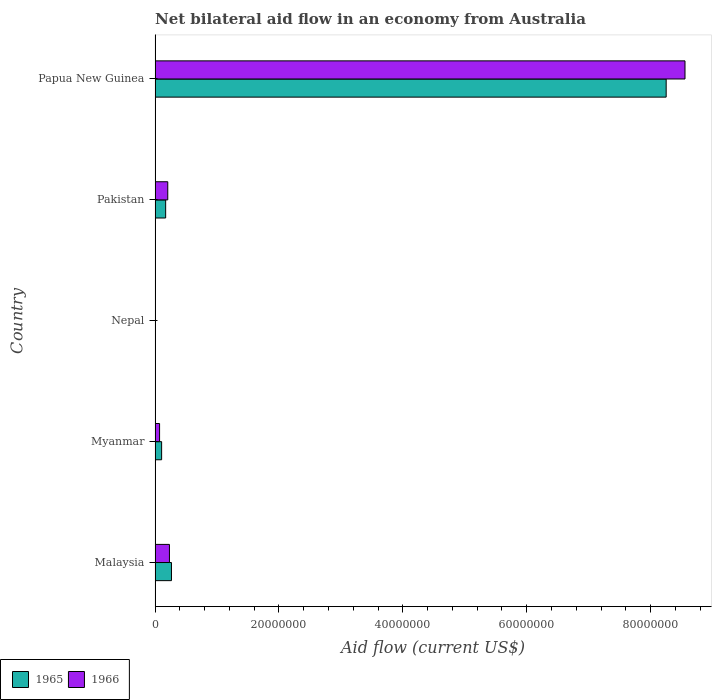How many different coloured bars are there?
Provide a succinct answer. 2. Are the number of bars on each tick of the Y-axis equal?
Make the answer very short. Yes. How many bars are there on the 3rd tick from the bottom?
Ensure brevity in your answer.  2. What is the label of the 4th group of bars from the top?
Your answer should be very brief. Myanmar. Across all countries, what is the maximum net bilateral aid flow in 1966?
Provide a short and direct response. 8.56e+07. Across all countries, what is the minimum net bilateral aid flow in 1965?
Provide a succinct answer. 5.00e+04. In which country was the net bilateral aid flow in 1966 maximum?
Provide a short and direct response. Papua New Guinea. In which country was the net bilateral aid flow in 1965 minimum?
Provide a succinct answer. Nepal. What is the total net bilateral aid flow in 1965 in the graph?
Your response must be concise. 8.80e+07. What is the difference between the net bilateral aid flow in 1966 in Malaysia and that in Myanmar?
Your answer should be very brief. 1.59e+06. What is the difference between the net bilateral aid flow in 1966 in Nepal and the net bilateral aid flow in 1965 in Pakistan?
Provide a succinct answer. -1.65e+06. What is the average net bilateral aid flow in 1966 per country?
Provide a succinct answer. 1.81e+07. What is the ratio of the net bilateral aid flow in 1965 in Myanmar to that in Papua New Guinea?
Ensure brevity in your answer.  0.01. Is the net bilateral aid flow in 1966 in Nepal less than that in Pakistan?
Ensure brevity in your answer.  Yes. Is the difference between the net bilateral aid flow in 1965 in Malaysia and Papua New Guinea greater than the difference between the net bilateral aid flow in 1966 in Malaysia and Papua New Guinea?
Provide a succinct answer. Yes. What is the difference between the highest and the second highest net bilateral aid flow in 1966?
Your response must be concise. 8.32e+07. What is the difference between the highest and the lowest net bilateral aid flow in 1966?
Make the answer very short. 8.55e+07. In how many countries, is the net bilateral aid flow in 1966 greater than the average net bilateral aid flow in 1966 taken over all countries?
Provide a short and direct response. 1. Is the sum of the net bilateral aid flow in 1966 in Myanmar and Nepal greater than the maximum net bilateral aid flow in 1965 across all countries?
Keep it short and to the point. No. What does the 1st bar from the top in Pakistan represents?
Ensure brevity in your answer.  1966. What does the 2nd bar from the bottom in Myanmar represents?
Give a very brief answer. 1966. How are the legend labels stacked?
Give a very brief answer. Horizontal. What is the title of the graph?
Your response must be concise. Net bilateral aid flow in an economy from Australia. What is the label or title of the X-axis?
Keep it short and to the point. Aid flow (current US$). What is the label or title of the Y-axis?
Your response must be concise. Country. What is the Aid flow (current US$) of 1965 in Malaysia?
Ensure brevity in your answer.  2.65e+06. What is the Aid flow (current US$) in 1966 in Malaysia?
Make the answer very short. 2.32e+06. What is the Aid flow (current US$) in 1965 in Myanmar?
Ensure brevity in your answer.  1.06e+06. What is the Aid flow (current US$) in 1966 in Myanmar?
Offer a terse response. 7.30e+05. What is the Aid flow (current US$) of 1965 in Pakistan?
Your answer should be compact. 1.71e+06. What is the Aid flow (current US$) in 1966 in Pakistan?
Your answer should be very brief. 2.05e+06. What is the Aid flow (current US$) of 1965 in Papua New Guinea?
Make the answer very short. 8.25e+07. What is the Aid flow (current US$) of 1966 in Papua New Guinea?
Offer a very short reply. 8.56e+07. Across all countries, what is the maximum Aid flow (current US$) of 1965?
Provide a short and direct response. 8.25e+07. Across all countries, what is the maximum Aid flow (current US$) of 1966?
Offer a very short reply. 8.56e+07. Across all countries, what is the minimum Aid flow (current US$) of 1966?
Ensure brevity in your answer.  6.00e+04. What is the total Aid flow (current US$) in 1965 in the graph?
Give a very brief answer. 8.80e+07. What is the total Aid flow (current US$) of 1966 in the graph?
Provide a short and direct response. 9.07e+07. What is the difference between the Aid flow (current US$) in 1965 in Malaysia and that in Myanmar?
Ensure brevity in your answer.  1.59e+06. What is the difference between the Aid flow (current US$) in 1966 in Malaysia and that in Myanmar?
Provide a short and direct response. 1.59e+06. What is the difference between the Aid flow (current US$) of 1965 in Malaysia and that in Nepal?
Provide a short and direct response. 2.60e+06. What is the difference between the Aid flow (current US$) in 1966 in Malaysia and that in Nepal?
Ensure brevity in your answer.  2.26e+06. What is the difference between the Aid flow (current US$) of 1965 in Malaysia and that in Pakistan?
Your response must be concise. 9.40e+05. What is the difference between the Aid flow (current US$) in 1965 in Malaysia and that in Papua New Guinea?
Your response must be concise. -7.99e+07. What is the difference between the Aid flow (current US$) of 1966 in Malaysia and that in Papua New Guinea?
Give a very brief answer. -8.32e+07. What is the difference between the Aid flow (current US$) of 1965 in Myanmar and that in Nepal?
Give a very brief answer. 1.01e+06. What is the difference between the Aid flow (current US$) of 1966 in Myanmar and that in Nepal?
Offer a terse response. 6.70e+05. What is the difference between the Aid flow (current US$) of 1965 in Myanmar and that in Pakistan?
Keep it short and to the point. -6.50e+05. What is the difference between the Aid flow (current US$) of 1966 in Myanmar and that in Pakistan?
Your response must be concise. -1.32e+06. What is the difference between the Aid flow (current US$) of 1965 in Myanmar and that in Papua New Guinea?
Provide a short and direct response. -8.14e+07. What is the difference between the Aid flow (current US$) in 1966 in Myanmar and that in Papua New Guinea?
Your answer should be compact. -8.48e+07. What is the difference between the Aid flow (current US$) of 1965 in Nepal and that in Pakistan?
Keep it short and to the point. -1.66e+06. What is the difference between the Aid flow (current US$) of 1966 in Nepal and that in Pakistan?
Provide a short and direct response. -1.99e+06. What is the difference between the Aid flow (current US$) in 1965 in Nepal and that in Papua New Guinea?
Make the answer very short. -8.25e+07. What is the difference between the Aid flow (current US$) in 1966 in Nepal and that in Papua New Guinea?
Offer a very short reply. -8.55e+07. What is the difference between the Aid flow (current US$) of 1965 in Pakistan and that in Papua New Guinea?
Keep it short and to the point. -8.08e+07. What is the difference between the Aid flow (current US$) of 1966 in Pakistan and that in Papua New Guinea?
Provide a short and direct response. -8.35e+07. What is the difference between the Aid flow (current US$) of 1965 in Malaysia and the Aid flow (current US$) of 1966 in Myanmar?
Provide a succinct answer. 1.92e+06. What is the difference between the Aid flow (current US$) of 1965 in Malaysia and the Aid flow (current US$) of 1966 in Nepal?
Give a very brief answer. 2.59e+06. What is the difference between the Aid flow (current US$) in 1965 in Malaysia and the Aid flow (current US$) in 1966 in Pakistan?
Provide a short and direct response. 6.00e+05. What is the difference between the Aid flow (current US$) of 1965 in Malaysia and the Aid flow (current US$) of 1966 in Papua New Guinea?
Make the answer very short. -8.29e+07. What is the difference between the Aid flow (current US$) in 1965 in Myanmar and the Aid flow (current US$) in 1966 in Nepal?
Give a very brief answer. 1.00e+06. What is the difference between the Aid flow (current US$) of 1965 in Myanmar and the Aid flow (current US$) of 1966 in Pakistan?
Provide a succinct answer. -9.90e+05. What is the difference between the Aid flow (current US$) of 1965 in Myanmar and the Aid flow (current US$) of 1966 in Papua New Guinea?
Offer a very short reply. -8.45e+07. What is the difference between the Aid flow (current US$) of 1965 in Nepal and the Aid flow (current US$) of 1966 in Pakistan?
Offer a terse response. -2.00e+06. What is the difference between the Aid flow (current US$) in 1965 in Nepal and the Aid flow (current US$) in 1966 in Papua New Guinea?
Make the answer very short. -8.55e+07. What is the difference between the Aid flow (current US$) of 1965 in Pakistan and the Aid flow (current US$) of 1966 in Papua New Guinea?
Your answer should be compact. -8.38e+07. What is the average Aid flow (current US$) in 1965 per country?
Provide a succinct answer. 1.76e+07. What is the average Aid flow (current US$) in 1966 per country?
Keep it short and to the point. 1.81e+07. What is the difference between the Aid flow (current US$) of 1965 and Aid flow (current US$) of 1966 in Malaysia?
Ensure brevity in your answer.  3.30e+05. What is the difference between the Aid flow (current US$) in 1965 and Aid flow (current US$) in 1966 in Myanmar?
Make the answer very short. 3.30e+05. What is the difference between the Aid flow (current US$) in 1965 and Aid flow (current US$) in 1966 in Pakistan?
Ensure brevity in your answer.  -3.40e+05. What is the difference between the Aid flow (current US$) in 1965 and Aid flow (current US$) in 1966 in Papua New Guinea?
Provide a short and direct response. -3.04e+06. What is the ratio of the Aid flow (current US$) of 1965 in Malaysia to that in Myanmar?
Your answer should be compact. 2.5. What is the ratio of the Aid flow (current US$) in 1966 in Malaysia to that in Myanmar?
Provide a short and direct response. 3.18. What is the ratio of the Aid flow (current US$) in 1965 in Malaysia to that in Nepal?
Provide a succinct answer. 53. What is the ratio of the Aid flow (current US$) in 1966 in Malaysia to that in Nepal?
Make the answer very short. 38.67. What is the ratio of the Aid flow (current US$) in 1965 in Malaysia to that in Pakistan?
Keep it short and to the point. 1.55. What is the ratio of the Aid flow (current US$) of 1966 in Malaysia to that in Pakistan?
Make the answer very short. 1.13. What is the ratio of the Aid flow (current US$) in 1965 in Malaysia to that in Papua New Guinea?
Provide a short and direct response. 0.03. What is the ratio of the Aid flow (current US$) in 1966 in Malaysia to that in Papua New Guinea?
Offer a very short reply. 0.03. What is the ratio of the Aid flow (current US$) of 1965 in Myanmar to that in Nepal?
Ensure brevity in your answer.  21.2. What is the ratio of the Aid flow (current US$) in 1966 in Myanmar to that in Nepal?
Give a very brief answer. 12.17. What is the ratio of the Aid flow (current US$) in 1965 in Myanmar to that in Pakistan?
Your answer should be very brief. 0.62. What is the ratio of the Aid flow (current US$) of 1966 in Myanmar to that in Pakistan?
Give a very brief answer. 0.36. What is the ratio of the Aid flow (current US$) of 1965 in Myanmar to that in Papua New Guinea?
Provide a short and direct response. 0.01. What is the ratio of the Aid flow (current US$) in 1966 in Myanmar to that in Papua New Guinea?
Offer a very short reply. 0.01. What is the ratio of the Aid flow (current US$) of 1965 in Nepal to that in Pakistan?
Give a very brief answer. 0.03. What is the ratio of the Aid flow (current US$) of 1966 in Nepal to that in Pakistan?
Give a very brief answer. 0.03. What is the ratio of the Aid flow (current US$) of 1965 in Nepal to that in Papua New Guinea?
Offer a terse response. 0. What is the ratio of the Aid flow (current US$) in 1966 in Nepal to that in Papua New Guinea?
Make the answer very short. 0. What is the ratio of the Aid flow (current US$) in 1965 in Pakistan to that in Papua New Guinea?
Offer a very short reply. 0.02. What is the ratio of the Aid flow (current US$) of 1966 in Pakistan to that in Papua New Guinea?
Your response must be concise. 0.02. What is the difference between the highest and the second highest Aid flow (current US$) of 1965?
Make the answer very short. 7.99e+07. What is the difference between the highest and the second highest Aid flow (current US$) of 1966?
Give a very brief answer. 8.32e+07. What is the difference between the highest and the lowest Aid flow (current US$) of 1965?
Offer a very short reply. 8.25e+07. What is the difference between the highest and the lowest Aid flow (current US$) in 1966?
Ensure brevity in your answer.  8.55e+07. 